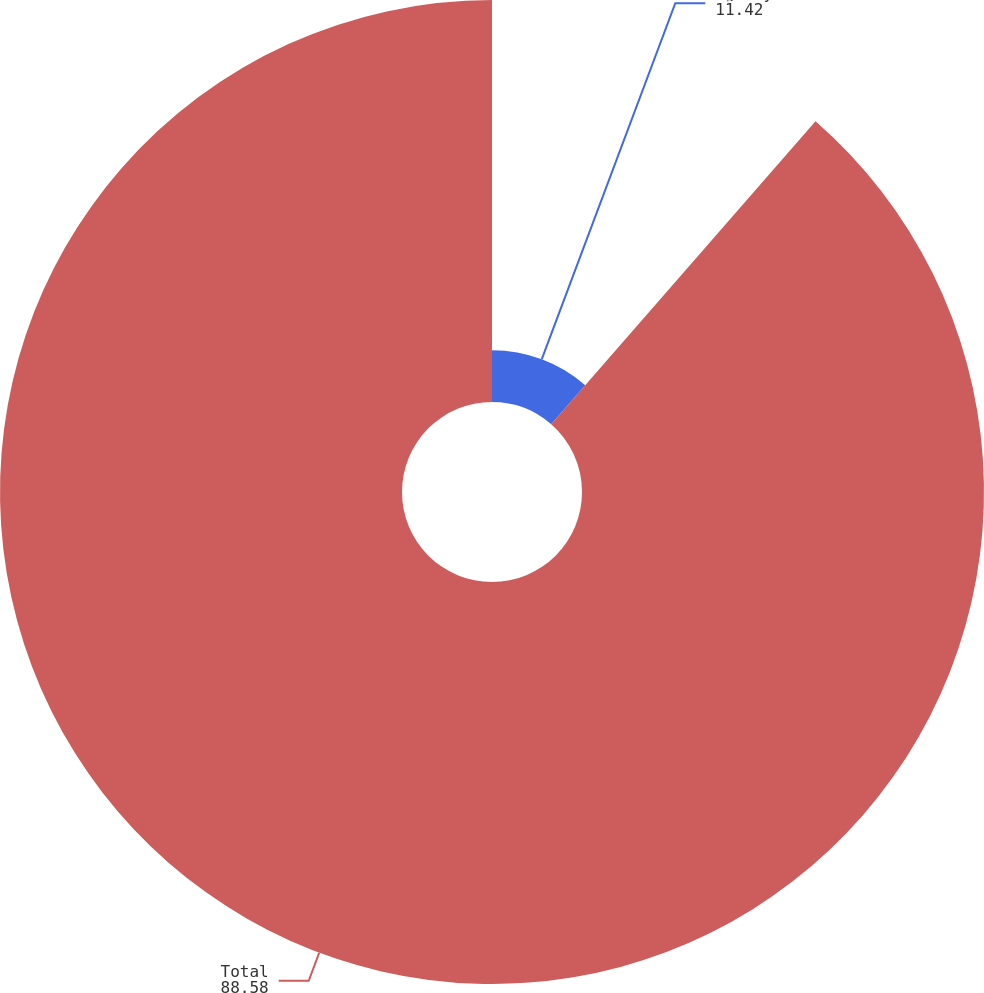Convert chart to OTSL. <chart><loc_0><loc_0><loc_500><loc_500><pie_chart><fcel>Agency MBS and CMOs<fcel>Total<nl><fcel>11.42%<fcel>88.58%<nl></chart> 